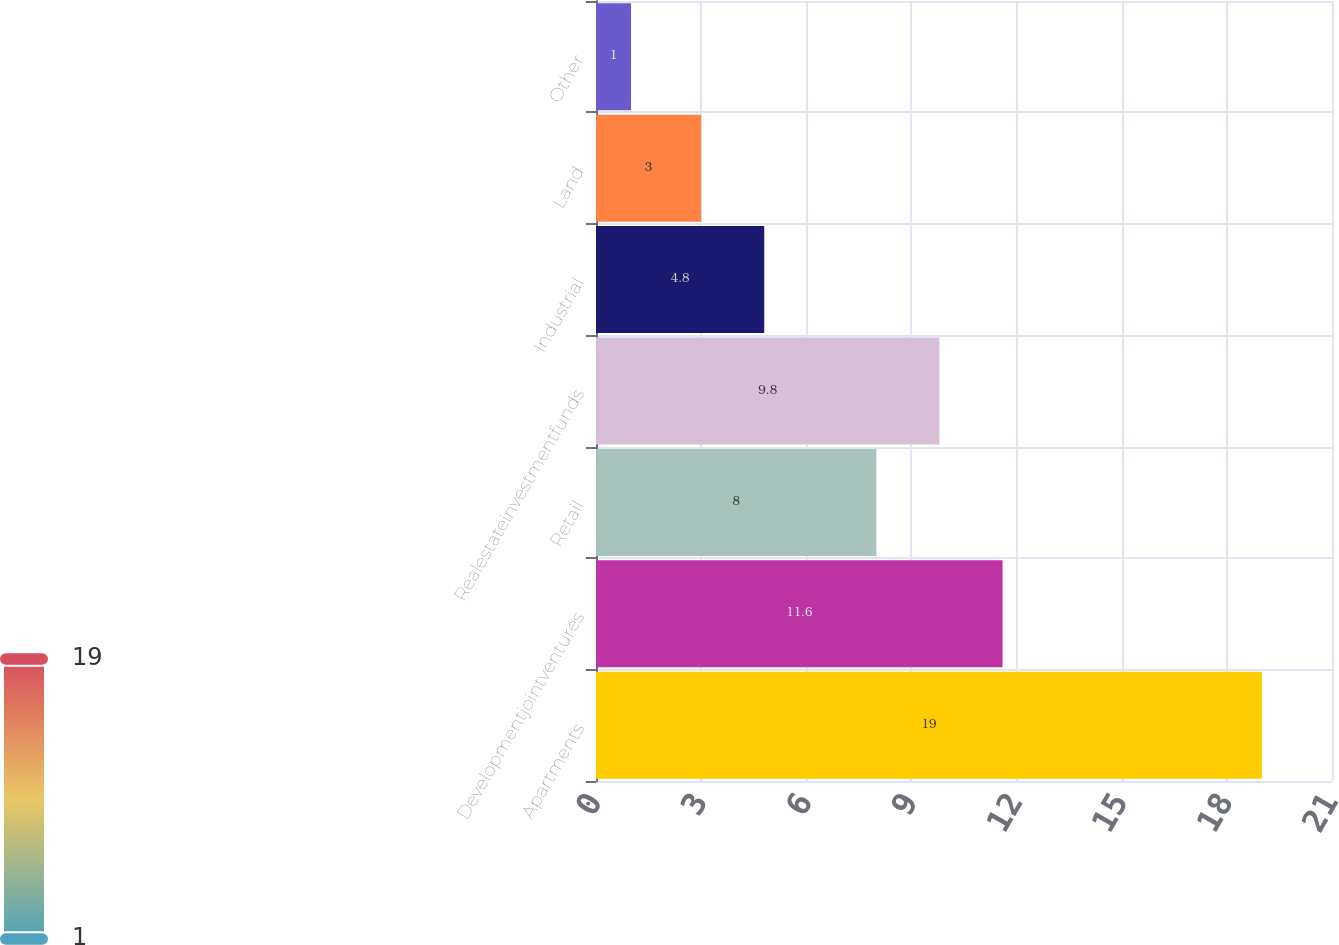<chart> <loc_0><loc_0><loc_500><loc_500><bar_chart><fcel>Apartments<fcel>Developmentjointventures<fcel>Retail<fcel>Realestateinvestmentfunds<fcel>Industrial<fcel>Land<fcel>Other<nl><fcel>19<fcel>11.6<fcel>8<fcel>9.8<fcel>4.8<fcel>3<fcel>1<nl></chart> 